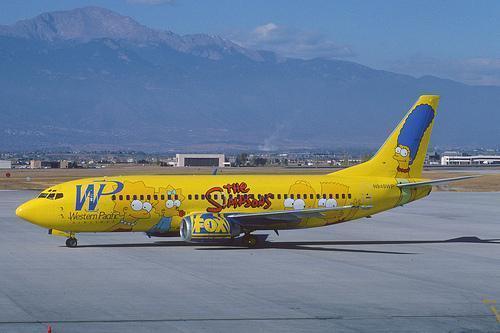How many planes?
Give a very brief answer. 1. 